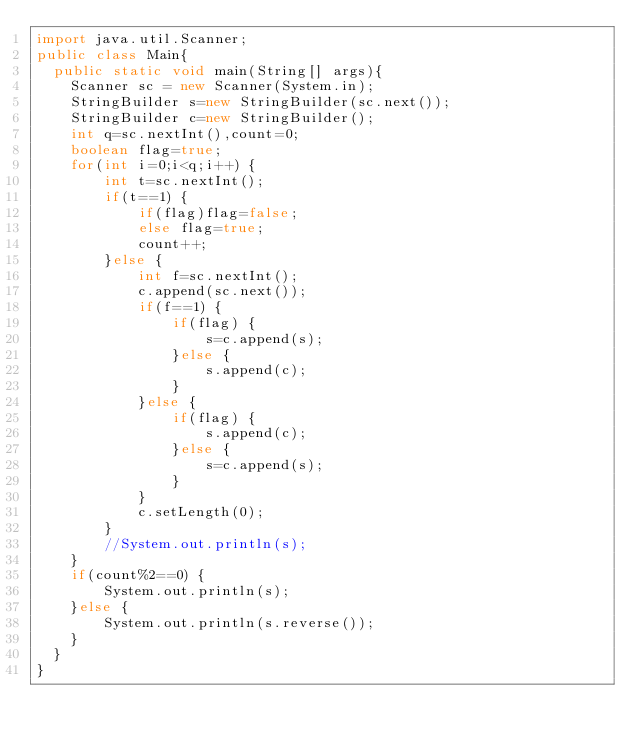Convert code to text. <code><loc_0><loc_0><loc_500><loc_500><_Java_>import java.util.Scanner;
public class Main{
  public static void main(String[] args){
    Scanner sc = new Scanner(System.in);
    StringBuilder s=new StringBuilder(sc.next());
    StringBuilder c=new StringBuilder();
    int q=sc.nextInt(),count=0;
    boolean flag=true;
    for(int i=0;i<q;i++) {
    	int t=sc.nextInt();
    	if(t==1) {
    		if(flag)flag=false;
    		else flag=true;
    		count++;
    	}else {
    		int f=sc.nextInt();
    		c.append(sc.next());
    		if(f==1) {
    			if(flag) {
    				s=c.append(s);
    			}else {
    				s.append(c);
    			}
    		}else {
    			if(flag) {
    				s.append(c);
    			}else {
    				s=c.append(s);
    			}
    		}
    		c.setLength(0);
    	}
    	//System.out.println(s);
    }
    if(count%2==0) {
    	System.out.println(s);
    }else {
    	System.out.println(s.reverse());
    }
  }
}
</code> 